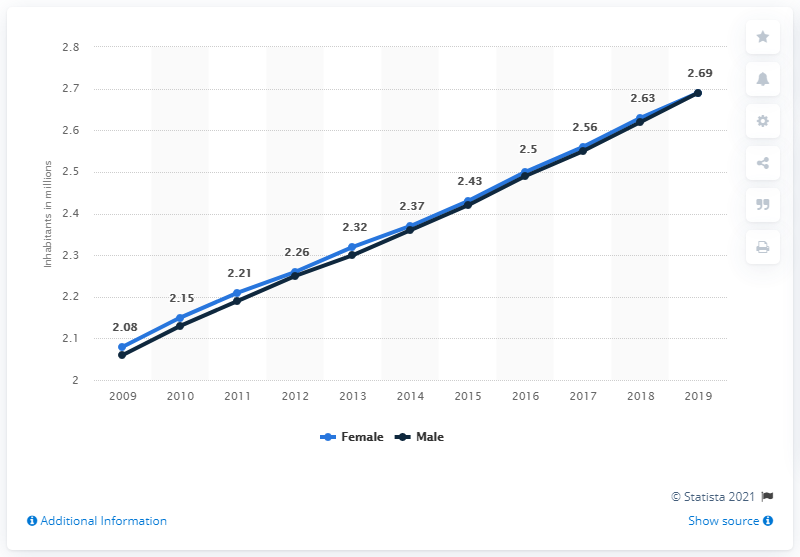Indicate a few pertinent items in this graphic. According to estimates, the female population of the Republic of the Congo in 2019 was approximately 2.69 million. In 2019, the female population of the Republic of the Congo was estimated to be 2.69 million. 